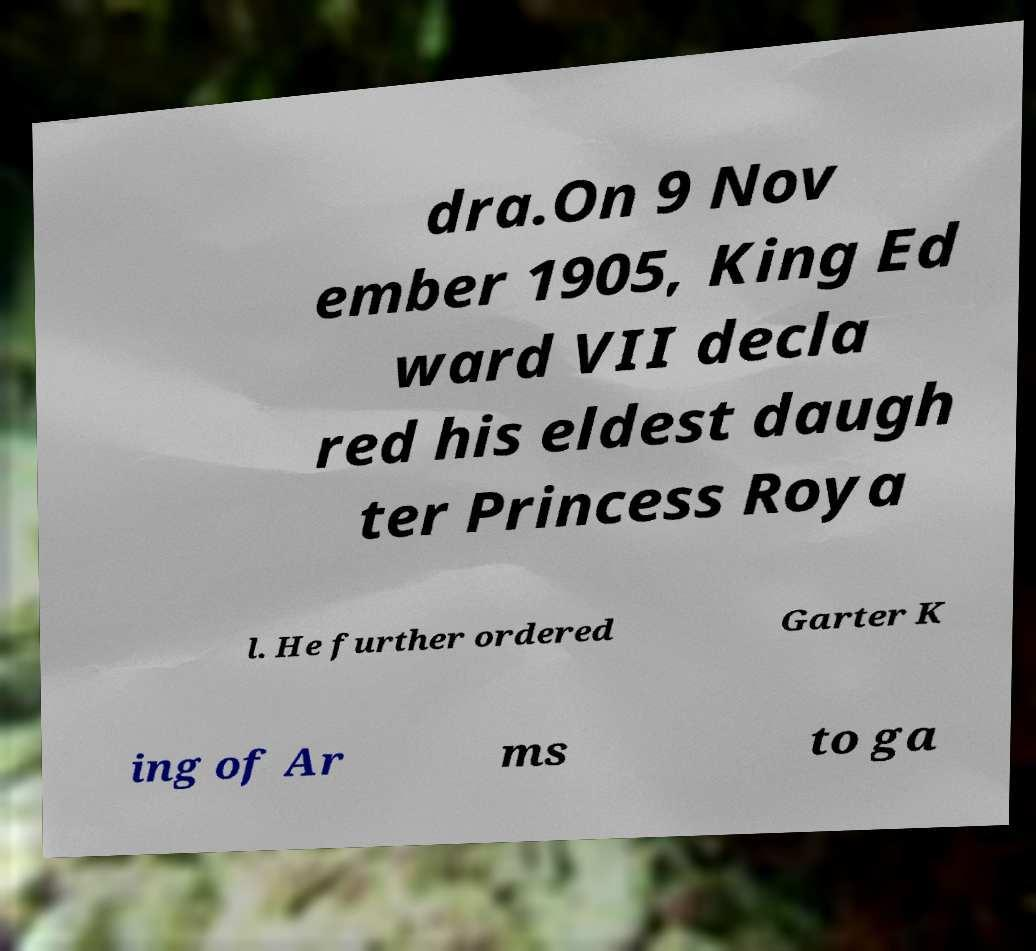What messages or text are displayed in this image? I need them in a readable, typed format. dra.On 9 Nov ember 1905, King Ed ward VII decla red his eldest daugh ter Princess Roya l. He further ordered Garter K ing of Ar ms to ga 